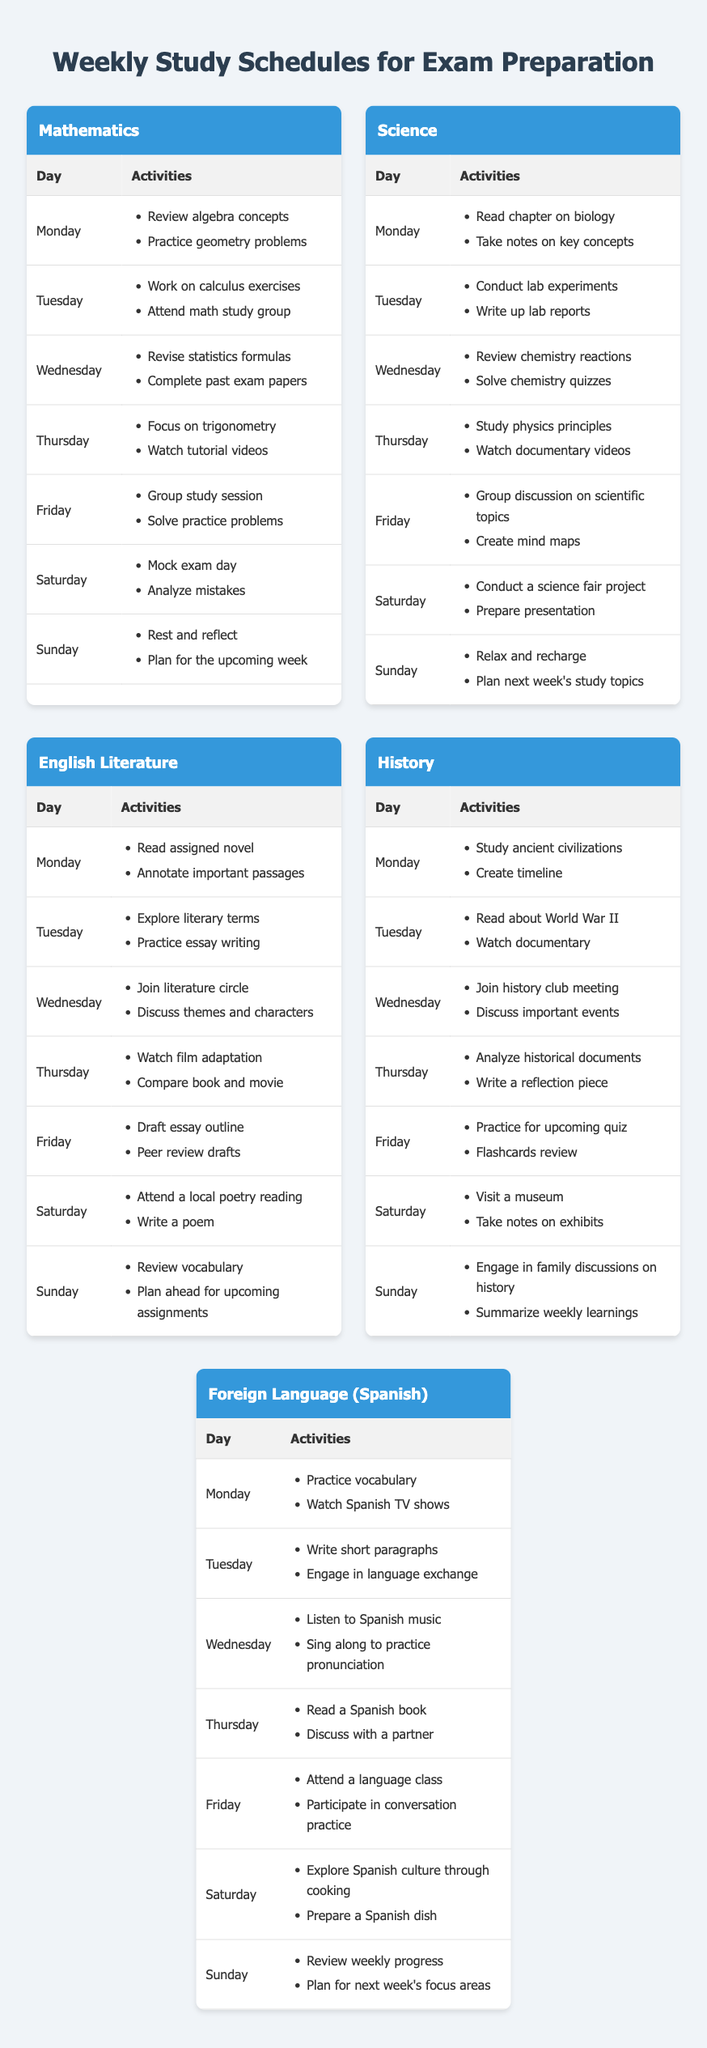What activities are planned for Tuesday in Mathematics? On Tuesday, the activities listed for Mathematics are "Work on calculus exercises" and "Attend math study group." These activities can be found in the corresponding row for Tuesday in the Mathematics schedule.
Answer: Work on calculus exercises, Attend math study group Which subject includes activities related to poetry on Saturday? The subject that includes activities related to poetry on Saturday is English Literature, where the activities are "Attend a local poetry reading" and "Write a poem." This can be found in the schedule for English Literature on that day.
Answer: English Literature How many total activities are planned for Sunday across all subjects? To find the total activities for Sunday, we look at each subject's activities for that day: Mathematics has 2 activities, Science has 2 activities, English Literature has 2 activities, History has 2 activities, and Foreign Language (Spanish) has 2 activities. Adding them up: 2 + 2 + 2 + 2 + 2 = 10 activities in total for Sunday across all subjects.
Answer: 10 Does the Science schedule include discussing important events? No, the Science schedule does not include discussing important events. This activity is present in the History schedule for Wednesday, but not in the Science schedule. Therefore, the answer is no.
Answer: No Which subject has the most activities designated for Monday? Both Mathematics and Science have 2 activities scheduled for Monday, but none of the subjects listed has more than 2 activities for that day. Thus, they are tied for the most activities.
Answer: Mathematics and Science 